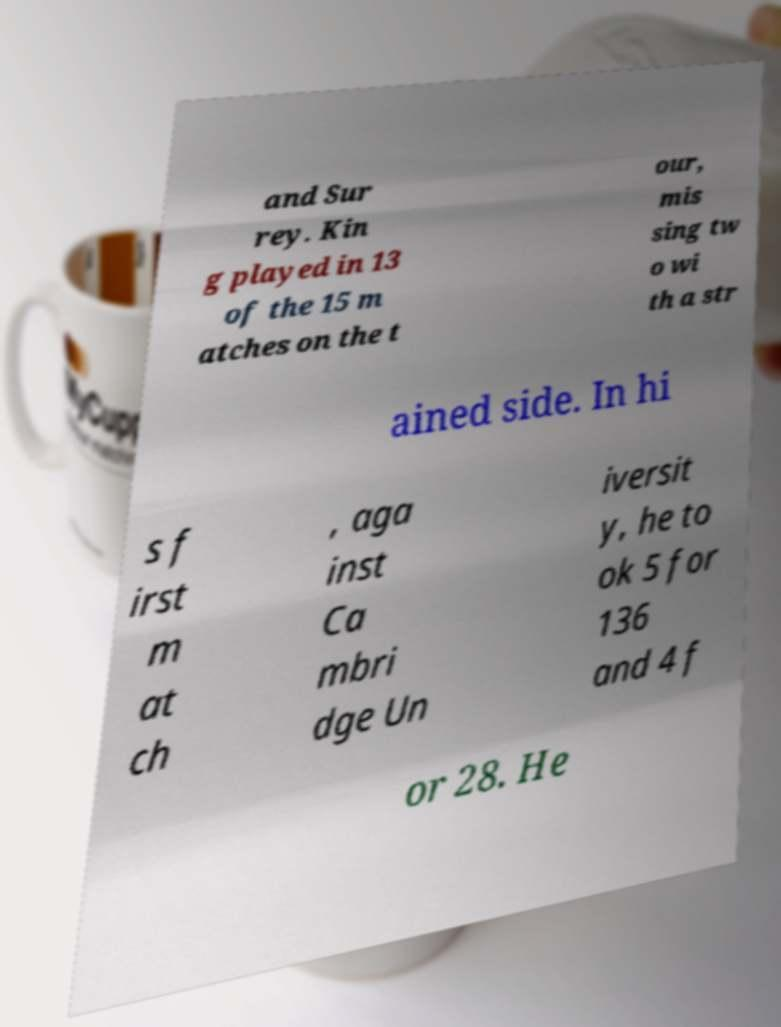Could you assist in decoding the text presented in this image and type it out clearly? and Sur rey. Kin g played in 13 of the 15 m atches on the t our, mis sing tw o wi th a str ained side. In hi s f irst m at ch , aga inst Ca mbri dge Un iversit y, he to ok 5 for 136 and 4 f or 28. He 